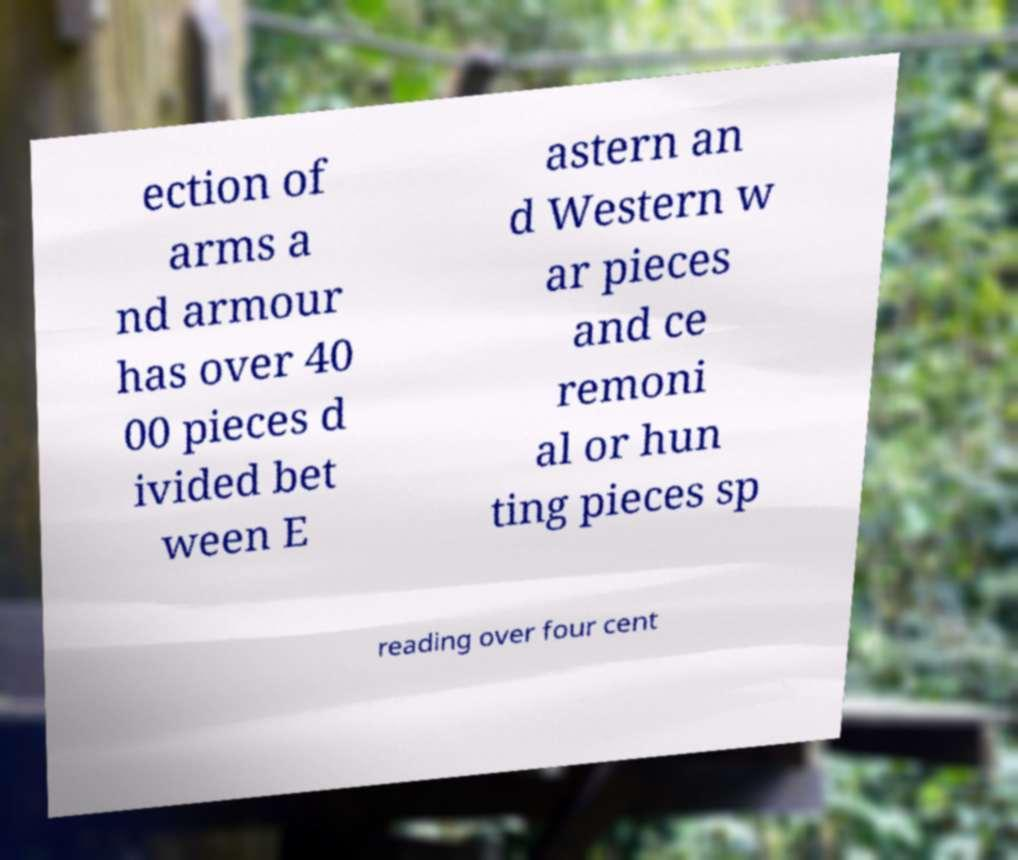Can you read and provide the text displayed in the image?This photo seems to have some interesting text. Can you extract and type it out for me? ection of arms a nd armour has over 40 00 pieces d ivided bet ween E astern an d Western w ar pieces and ce remoni al or hun ting pieces sp reading over four cent 